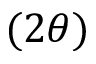<formula> <loc_0><loc_0><loc_500><loc_500>( 2 \theta )</formula> 